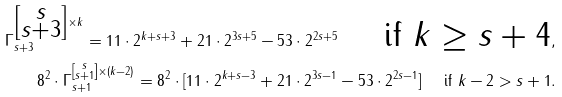Convert formula to latex. <formula><loc_0><loc_0><loc_500><loc_500>\Gamma _ { s + 3 } ^ { \left [ \substack { s \\ s + 3 } \right ] \times k } = 1 1 \cdot 2 ^ { k + s + 3 } + 2 1 \cdot 2 ^ { 3 s + 5 } - 5 3 \cdot 2 ^ { 2 s + 5 } \quad \text { if $ k \geq s+ 4 $} , \\ 8 ^ { 2 } \cdot \Gamma _ { s + 1 } ^ { \left [ \substack { s \\ s + 1 } \right ] \times ( k - 2 ) } = 8 ^ { 2 } \cdot [ 1 1 \cdot 2 ^ { k + s - 3 } + 2 1 \cdot 2 ^ { 3 s - 1 } - 5 3 \cdot 2 ^ { 2 s - 1 } ] \quad \text { if $ k -2 > s+ 1 $} . \\ &</formula> 